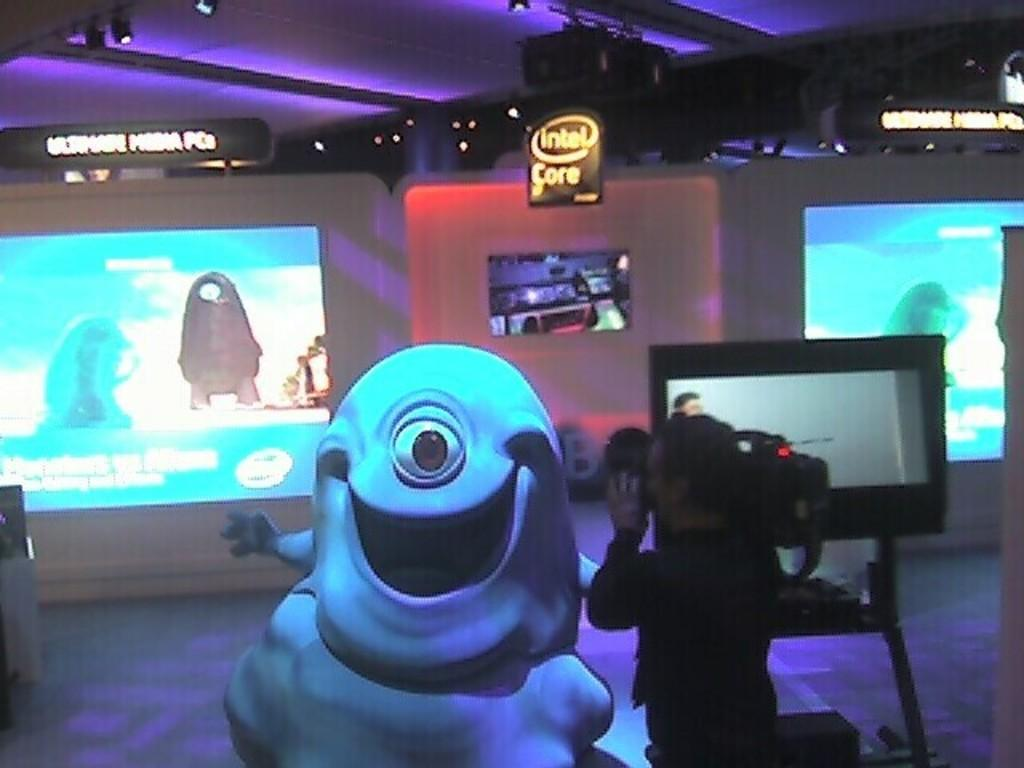<image>
Offer a succinct explanation of the picture presented. A person is filming a monster with one eye beneath a sign that says Intel Core. 